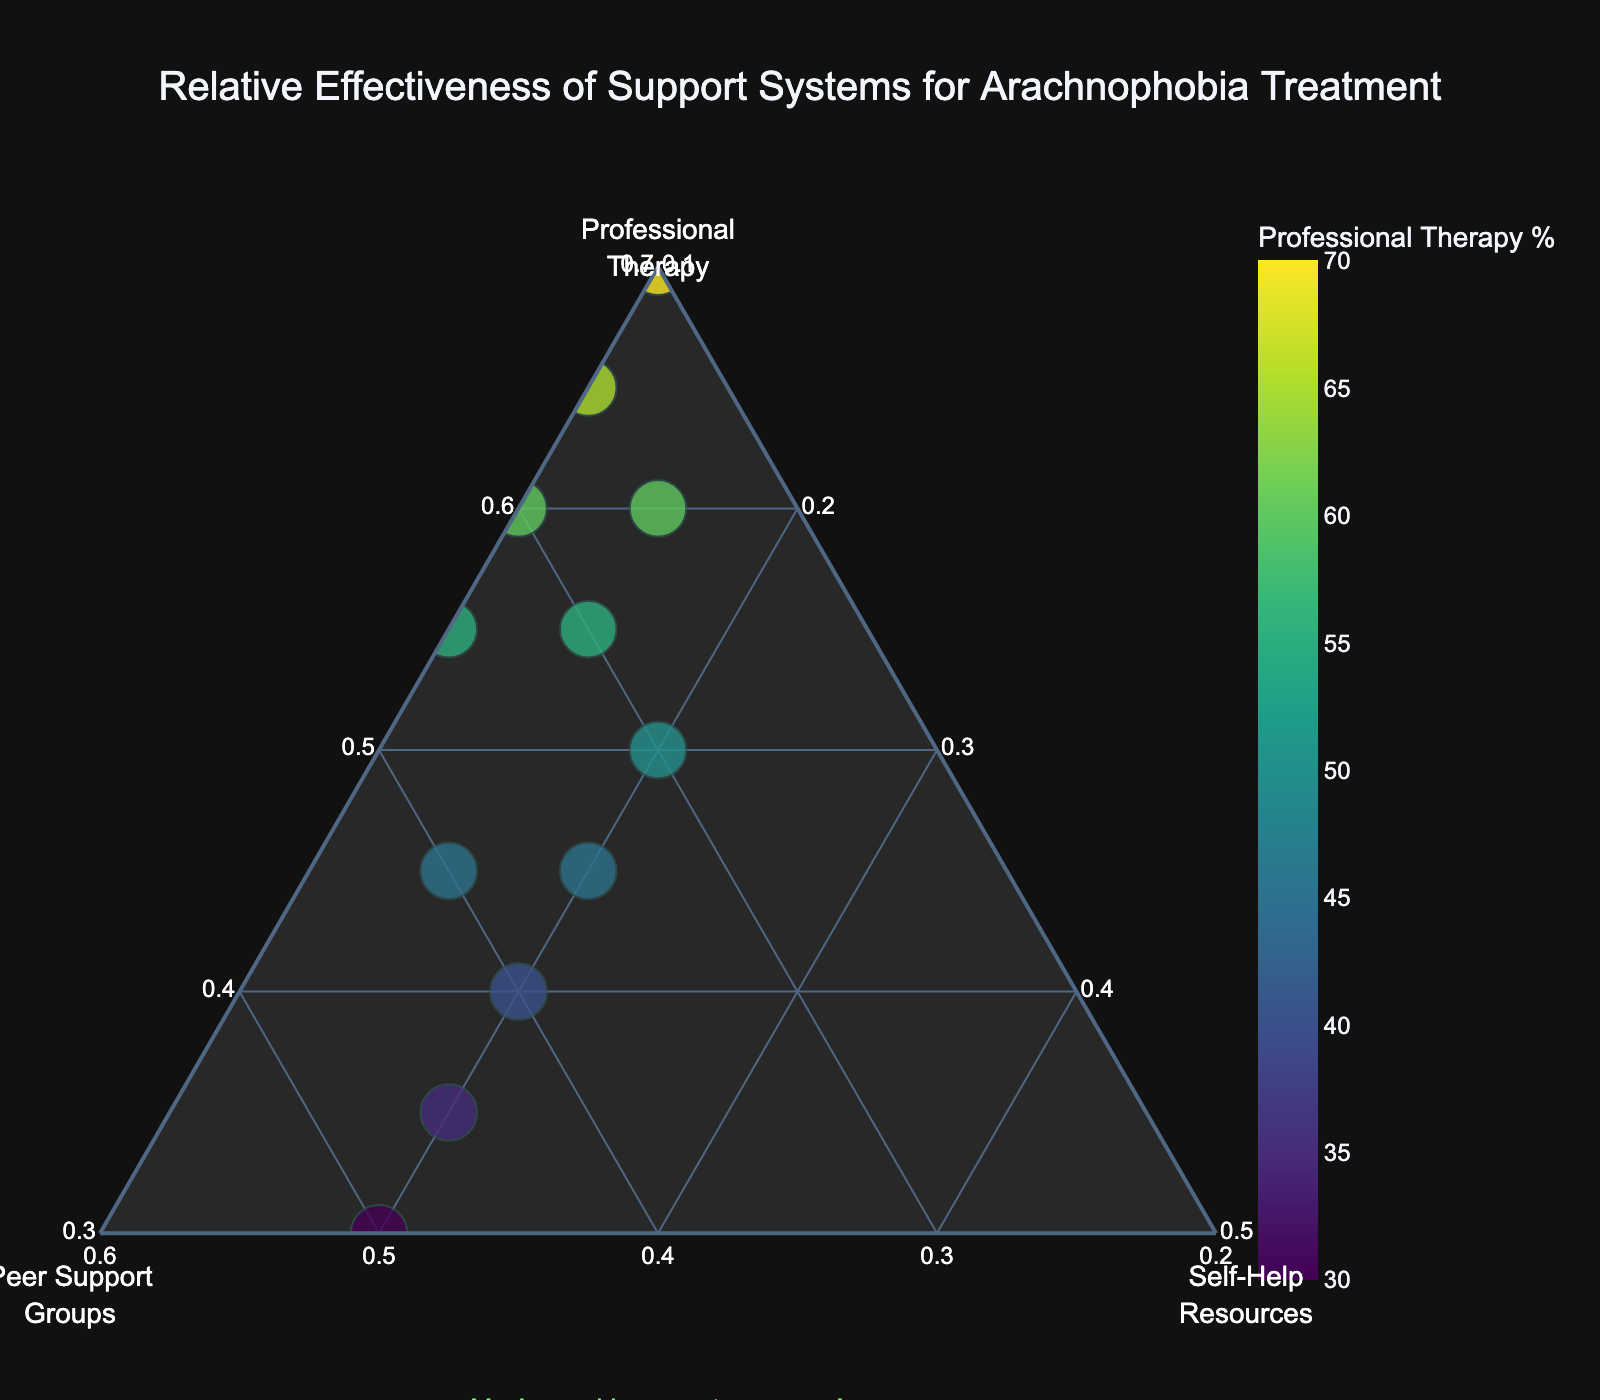What is the title of the ternary plot? The title is typically displayed at the top center of the plot. In this case, it is "Relative Effectiveness of Support Systems for Arachnophobia Treatment."
Answer: Relative Effectiveness of Support Systems for Arachnophobia Treatment Which axis represents the effectiveness of Professional Therapy? To determine this, look at the labels on the plot's axes. The axis titled "Professional<br>Therapy" represents the effectiveness of Professional Therapy.
Answer: Professional Therapy How many data points are plotted in the figure? There is one data point for each patient. Count the number of unique names or markers in the plot. In this dataset, there are 12 patients.
Answer: 12 Which patient relies most heavily on Peer Support Groups? Identify the point closest to the Peer Support Groups axis (labeled on the left side of the plot) with the highest value along this axis. Sophia Lee has the highest percentage for Peer Support Groups.
Answer: Sophia Lee Who has the most balanced support among the three systems? Look for the point closest to the center of the ternary plot, indicating more balanced support among all three systems. David Garcia appears to have a more balanced distribution among all supports.
Answer: David Garcia Which patient has the highest percentage of Professional Therapy? Identify the point closest to the Professional Therapy axis on the plot. Olivia Wilson shows the highest percentage for Professional Therapy.
Answer: Olivia Wilson Compare Emma Thompson and Noah Smith's reliance on Self-Help Resources. Who relies more on Self-Help Resources? Locate the points representing Emma Thompson and Noah Smith and compare their positions along the Self-Help Resources axis. Emma Thompson relies more on Self-Help Resources than Noah Smith.
Answer: Emma Thompson What is the range of percentages for Self-Help Resources among the patients? Look at the scale along the Self-Help Resources axis and identify the minimum and maximum values. The range is from 10% to 20%.
Answer: 10% to 20% Who has a higher reliance on Peer Support Groups, Michael Chen or James Parker? Compare their positions along the Peer Support Groups axis. Michael Chen has a higher reliance on Peer Support Groups than James Parker.
Answer: Michael Chen Which patient has the least total support from all resources combined? Determine the sizes of the markers representing the total amount of support for each patient. Ava Rodriguez has the smallest marker, indicating the least total support.
Answer: Ava Rodriguez 